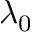Convert formula to latex. <formula><loc_0><loc_0><loc_500><loc_500>\lambda _ { 0 }</formula> 